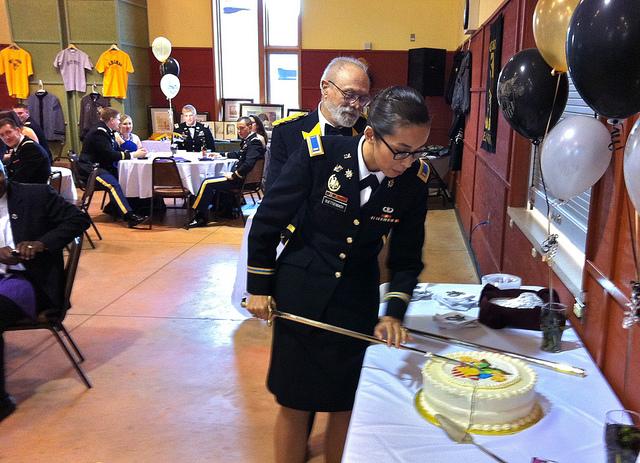What is she cutting the cake with?
Keep it brief. Sword. How many balloons are on the back table?
Give a very brief answer. 3. What kind of uniform is the lady wearing?
Give a very brief answer. Military. 